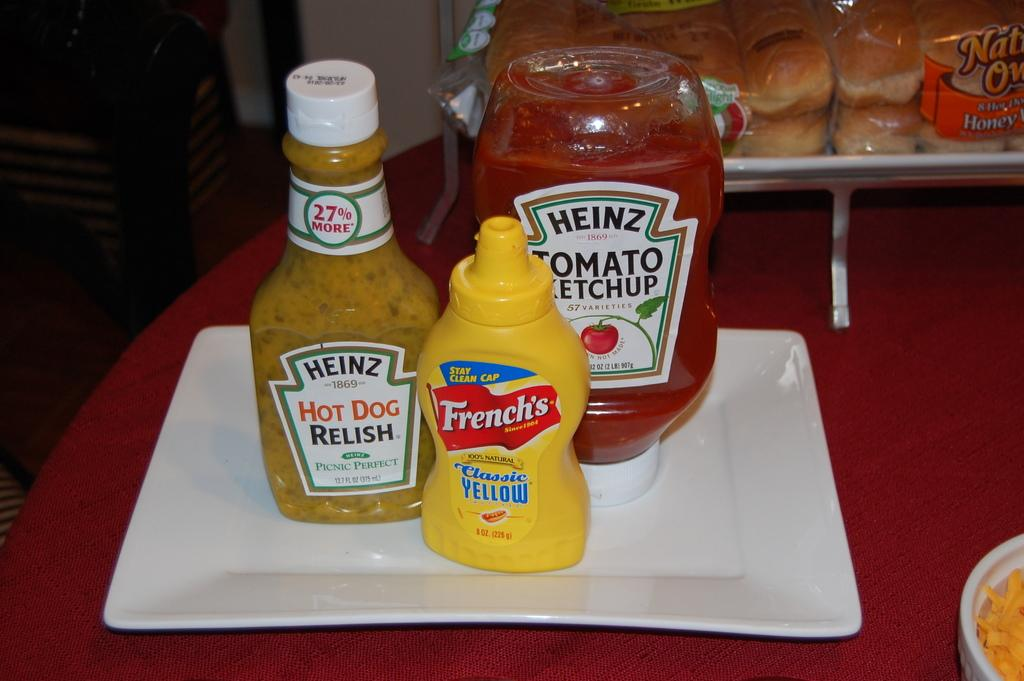<image>
Summarize the visual content of the image. Several bottles of Heinz products are on a white plate. 